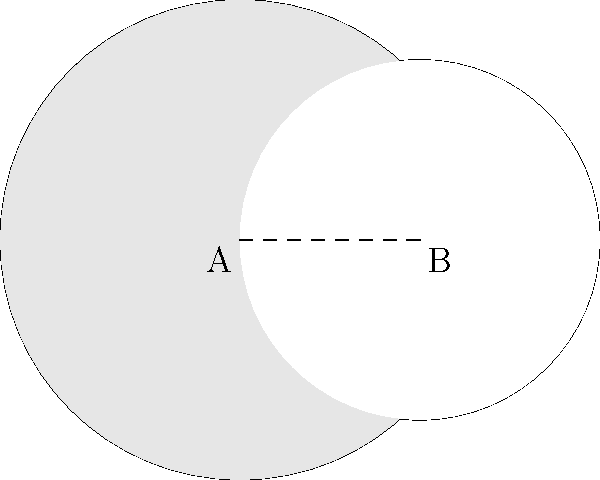In the diagram above, two circles with centers A and B overlap. Circle A has a radius of 4 units, and circle B has a radius of 3 units. The distance between their centers is 3 units. Calculate the area of the shaded region (the area of circle A that is not overlapped by circle B). Round your answer to two decimal places. To solve this problem, we'll follow these steps:

1) First, we need to find the area of the whole circle A:
   $$A_A = \pi r_A^2 = \pi \cdot 4^2 = 16\pi$$

2) Next, we need to find the area of the overlapping region (lens) and subtract it from the area of circle A.

3) To find the area of the lens, we can use the formula:
   $$A_{lens} = r_A^2 \arccos(\frac{d^2 + r_A^2 - r_B^2}{2dr_A}) + r_B^2 \arccos(\frac{d^2 + r_B^2 - r_A^2}{2dr_B}) - \frac{1}{2}\sqrt{(-d+r_A+r_B)(d+r_A-r_B)(d-r_A+r_B)(d+r_A+r_B)}$$

   Where:
   $r_A = 4$ (radius of circle A)
   $r_B = 3$ (radius of circle B)
   $d = 3$ (distance between centers)

4) Substituting these values:
   $$A_{lens} = 4^2 \arccos(\frac{3^2 + 4^2 - 3^2}{2\cdot3\cdot4}) + 3^2 \arccos(\frac{3^2 + 3^2 - 4^2}{2\cdot3\cdot3}) - \frac{1}{2}\sqrt{(-3+4+3)(3+4-3)(3-4+3)(3+4+3)}$$

5) Calculating this (you would typically use a calculator):
   $$A_{lens} \approx 9.74$$

6) Now, the shaded area is the difference between the area of circle A and the lens:
   $$A_{shaded} = A_A - A_{lens} = 16\pi - 9.74 \approx 40.53$$

7) Rounding to two decimal places: 40.53 square units.
Answer: 40.53 square units 